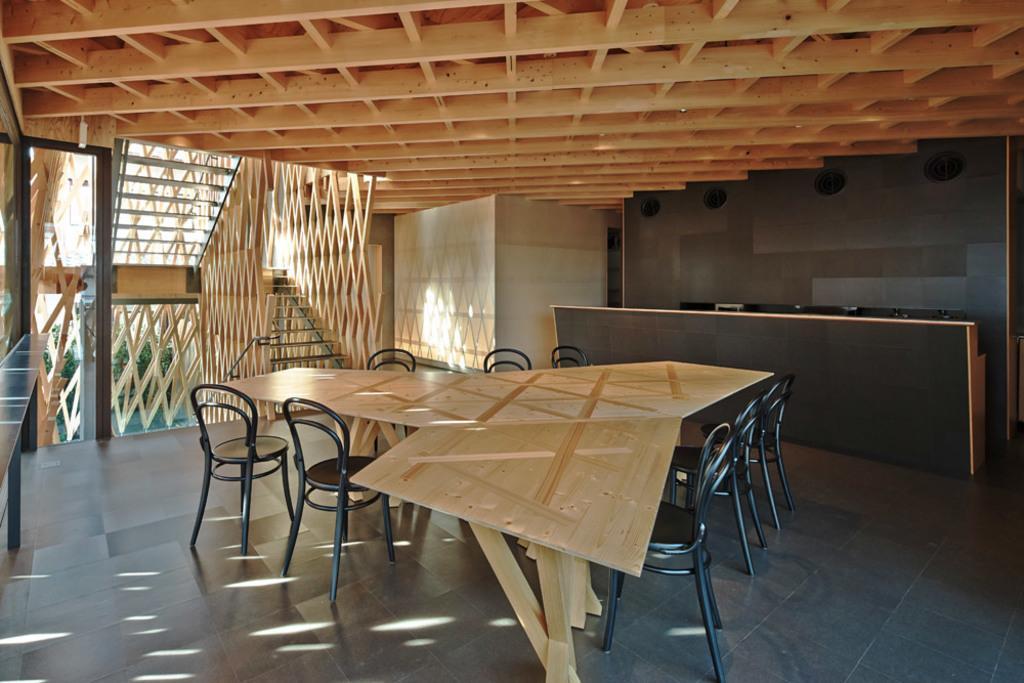Describe this image in one or two sentences. In this picture I can see the chairs and table. On the right I can see the laptops and computer screens on the desk. On the left I can see the wooden stairs and door. Through the door I can see the plants. 